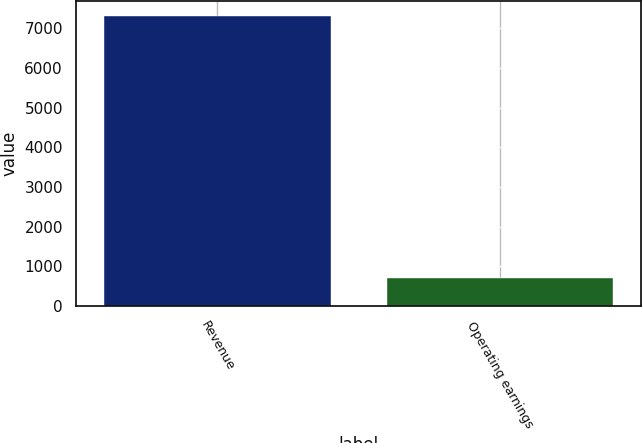<chart> <loc_0><loc_0><loc_500><loc_500><bar_chart><fcel>Revenue<fcel>Operating earnings<nl><fcel>7312<fcel>703<nl></chart> 